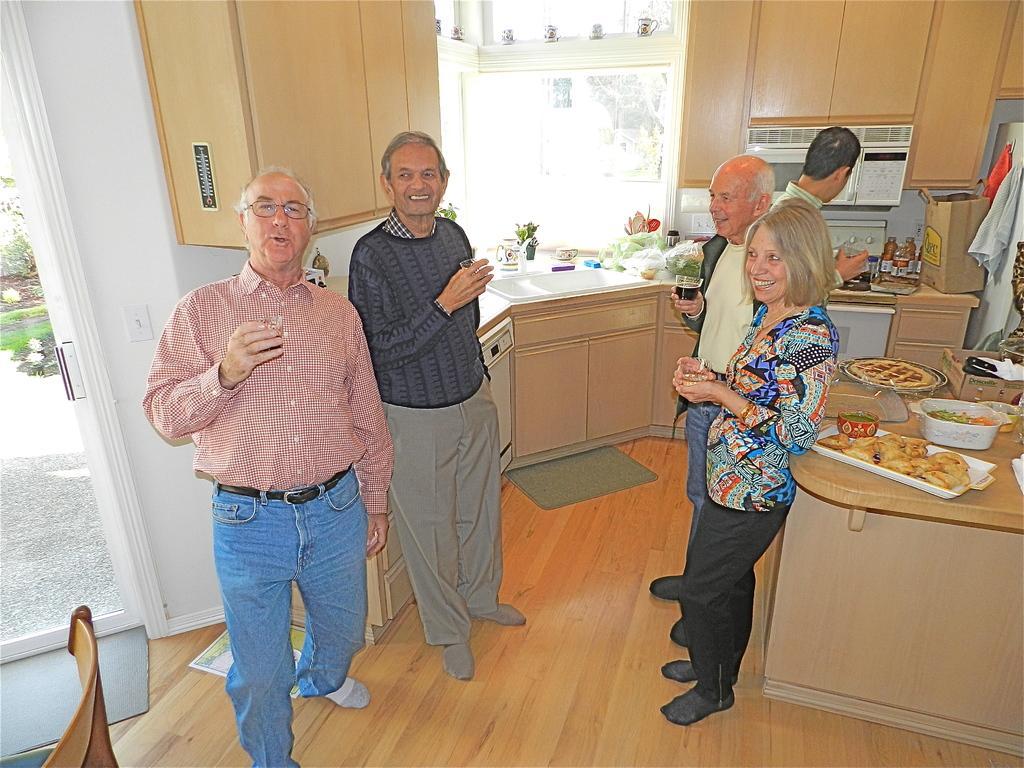Describe this image in one or two sentences. In this picture, we can see a few people holding some objects, and we can see the ground with some objects on it like, desks, chair, mats, and we can see some objects on the desks like food items served in a plate, bowls, we can see bags, bottles, and we can see the wall with shelves, glass, window, glass door, we can see the ground, plants from the glass door. 